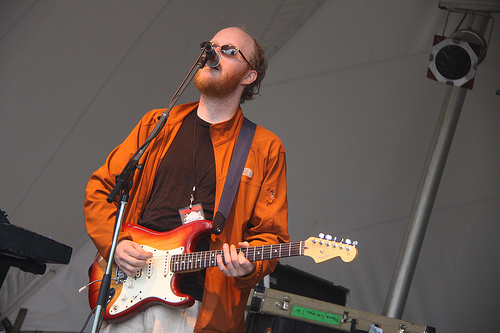<image>
Is there a mic in front of the man? Yes. The mic is positioned in front of the man, appearing closer to the camera viewpoint. 